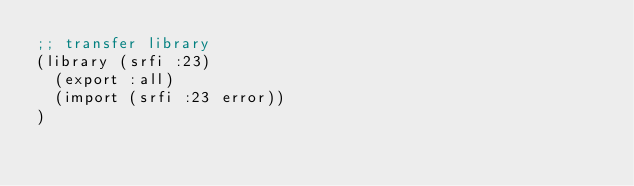Convert code to text. <code><loc_0><loc_0><loc_500><loc_500><_Scheme_>;; transfer library
(library (srfi :23)
  (export :all)
  (import (srfi :23 error))
)</code> 